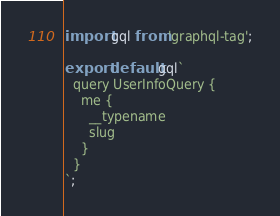Convert code to text. <code><loc_0><loc_0><loc_500><loc_500><_JavaScript_>import gql from 'graphql-tag';

export default gql`
  query UserInfoQuery {
    me {
      __typename
      slug
    }
  }
`;
</code> 